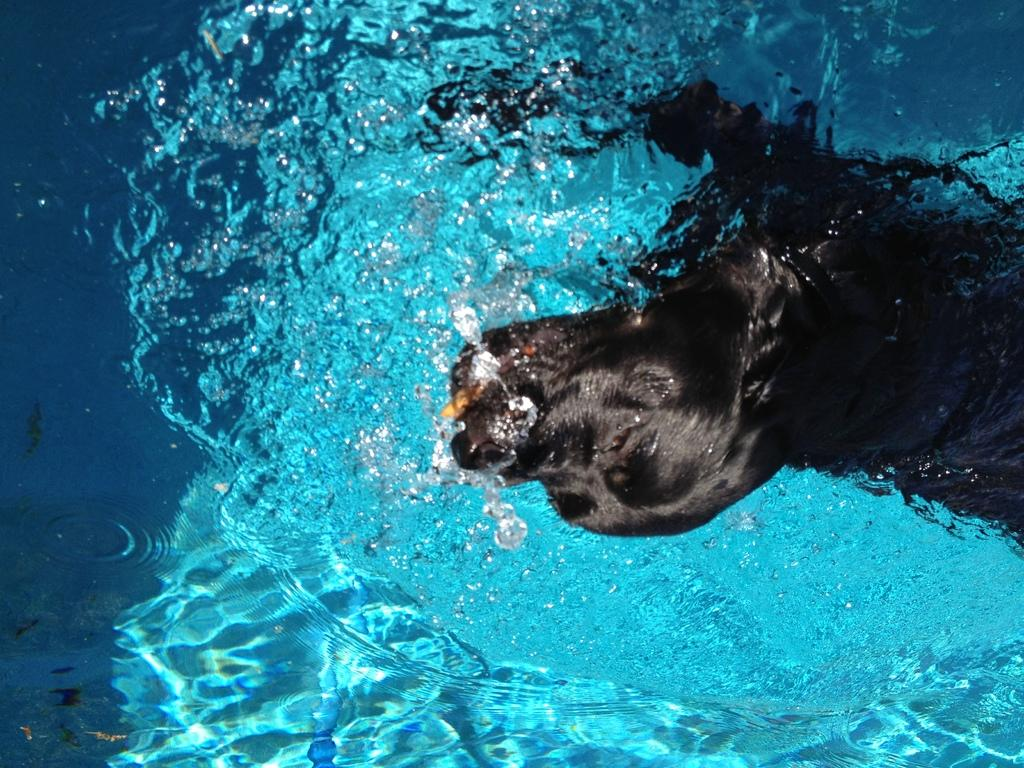What is the main subject of the image? There is a dog in the image. Where is the dog located in the image? The dog is in the center of the image. What is the dog's relationship with the water in the image? The dog is inside the water. What type of sidewalk can be seen in the image? There is no sidewalk present in the image; it features a dog inside the water. How does the scarf affect the dog's appearance in the image? There is no scarf present in the image, so its effect on the dog's appearance cannot be determined. 